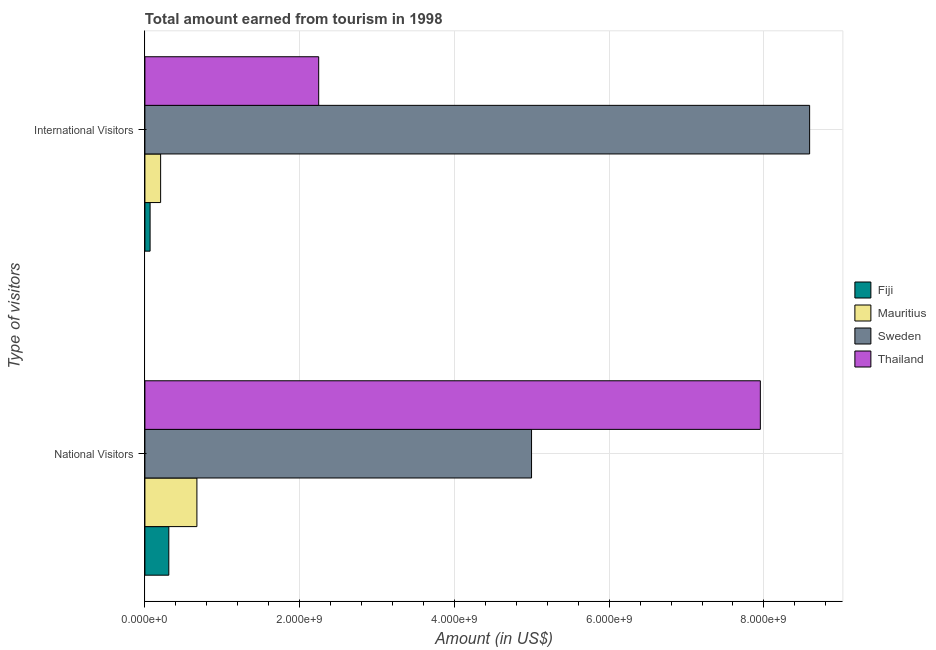Are the number of bars per tick equal to the number of legend labels?
Your answer should be very brief. Yes. Are the number of bars on each tick of the Y-axis equal?
Offer a terse response. Yes. What is the label of the 2nd group of bars from the top?
Give a very brief answer. National Visitors. What is the amount earned from international visitors in Mauritius?
Give a very brief answer. 2.03e+08. Across all countries, what is the maximum amount earned from international visitors?
Give a very brief answer. 8.59e+09. Across all countries, what is the minimum amount earned from national visitors?
Provide a succinct answer. 3.09e+08. In which country was the amount earned from international visitors minimum?
Your response must be concise. Fiji. What is the total amount earned from international visitors in the graph?
Offer a very short reply. 1.11e+1. What is the difference between the amount earned from national visitors in Sweden and that in Fiji?
Your answer should be very brief. 4.69e+09. What is the difference between the amount earned from international visitors in Sweden and the amount earned from national visitors in Mauritius?
Give a very brief answer. 7.92e+09. What is the average amount earned from national visitors per country?
Ensure brevity in your answer.  3.48e+09. What is the difference between the amount earned from international visitors and amount earned from national visitors in Fiji?
Provide a succinct answer. -2.42e+08. What is the ratio of the amount earned from international visitors in Mauritius to that in Thailand?
Your answer should be compact. 0.09. What does the 3rd bar from the top in National Visitors represents?
Give a very brief answer. Mauritius. What does the 2nd bar from the bottom in National Visitors represents?
Your answer should be very brief. Mauritius. Are all the bars in the graph horizontal?
Make the answer very short. Yes. What is the difference between two consecutive major ticks on the X-axis?
Provide a short and direct response. 2.00e+09. Are the values on the major ticks of X-axis written in scientific E-notation?
Give a very brief answer. Yes. Where does the legend appear in the graph?
Make the answer very short. Center right. How many legend labels are there?
Offer a very short reply. 4. What is the title of the graph?
Your response must be concise. Total amount earned from tourism in 1998. Does "Moldova" appear as one of the legend labels in the graph?
Offer a very short reply. No. What is the label or title of the X-axis?
Your answer should be compact. Amount (in US$). What is the label or title of the Y-axis?
Your answer should be very brief. Type of visitors. What is the Amount (in US$) in Fiji in National Visitors?
Provide a short and direct response. 3.09e+08. What is the Amount (in US$) of Mauritius in National Visitors?
Offer a very short reply. 6.72e+08. What is the Amount (in US$) of Sweden in National Visitors?
Ensure brevity in your answer.  5.00e+09. What is the Amount (in US$) in Thailand in National Visitors?
Your response must be concise. 7.95e+09. What is the Amount (in US$) of Fiji in International Visitors?
Offer a very short reply. 6.70e+07. What is the Amount (in US$) of Mauritius in International Visitors?
Make the answer very short. 2.03e+08. What is the Amount (in US$) of Sweden in International Visitors?
Provide a short and direct response. 8.59e+09. What is the Amount (in US$) in Thailand in International Visitors?
Your answer should be compact. 2.25e+09. Across all Type of visitors, what is the maximum Amount (in US$) of Fiji?
Give a very brief answer. 3.09e+08. Across all Type of visitors, what is the maximum Amount (in US$) of Mauritius?
Your answer should be compact. 6.72e+08. Across all Type of visitors, what is the maximum Amount (in US$) of Sweden?
Your response must be concise. 8.59e+09. Across all Type of visitors, what is the maximum Amount (in US$) of Thailand?
Your answer should be very brief. 7.95e+09. Across all Type of visitors, what is the minimum Amount (in US$) in Fiji?
Provide a short and direct response. 6.70e+07. Across all Type of visitors, what is the minimum Amount (in US$) of Mauritius?
Offer a terse response. 2.03e+08. Across all Type of visitors, what is the minimum Amount (in US$) in Sweden?
Keep it short and to the point. 5.00e+09. Across all Type of visitors, what is the minimum Amount (in US$) in Thailand?
Your answer should be very brief. 2.25e+09. What is the total Amount (in US$) of Fiji in the graph?
Your response must be concise. 3.76e+08. What is the total Amount (in US$) of Mauritius in the graph?
Your answer should be compact. 8.75e+08. What is the total Amount (in US$) of Sweden in the graph?
Provide a succinct answer. 1.36e+1. What is the total Amount (in US$) of Thailand in the graph?
Keep it short and to the point. 1.02e+1. What is the difference between the Amount (in US$) in Fiji in National Visitors and that in International Visitors?
Your answer should be very brief. 2.42e+08. What is the difference between the Amount (in US$) of Mauritius in National Visitors and that in International Visitors?
Offer a very short reply. 4.69e+08. What is the difference between the Amount (in US$) in Sweden in National Visitors and that in International Visitors?
Your answer should be compact. -3.59e+09. What is the difference between the Amount (in US$) in Thailand in National Visitors and that in International Visitors?
Offer a terse response. 5.71e+09. What is the difference between the Amount (in US$) of Fiji in National Visitors and the Amount (in US$) of Mauritius in International Visitors?
Keep it short and to the point. 1.06e+08. What is the difference between the Amount (in US$) in Fiji in National Visitors and the Amount (in US$) in Sweden in International Visitors?
Your answer should be compact. -8.28e+09. What is the difference between the Amount (in US$) of Fiji in National Visitors and the Amount (in US$) of Thailand in International Visitors?
Ensure brevity in your answer.  -1.94e+09. What is the difference between the Amount (in US$) in Mauritius in National Visitors and the Amount (in US$) in Sweden in International Visitors?
Give a very brief answer. -7.92e+09. What is the difference between the Amount (in US$) in Mauritius in National Visitors and the Amount (in US$) in Thailand in International Visitors?
Your answer should be very brief. -1.57e+09. What is the difference between the Amount (in US$) in Sweden in National Visitors and the Amount (in US$) in Thailand in International Visitors?
Provide a short and direct response. 2.75e+09. What is the average Amount (in US$) of Fiji per Type of visitors?
Provide a succinct answer. 1.88e+08. What is the average Amount (in US$) in Mauritius per Type of visitors?
Your answer should be very brief. 4.38e+08. What is the average Amount (in US$) in Sweden per Type of visitors?
Your answer should be compact. 6.79e+09. What is the average Amount (in US$) in Thailand per Type of visitors?
Provide a short and direct response. 5.10e+09. What is the difference between the Amount (in US$) in Fiji and Amount (in US$) in Mauritius in National Visitors?
Offer a terse response. -3.63e+08. What is the difference between the Amount (in US$) in Fiji and Amount (in US$) in Sweden in National Visitors?
Your response must be concise. -4.69e+09. What is the difference between the Amount (in US$) in Fiji and Amount (in US$) in Thailand in National Visitors?
Your answer should be compact. -7.64e+09. What is the difference between the Amount (in US$) in Mauritius and Amount (in US$) in Sweden in National Visitors?
Give a very brief answer. -4.32e+09. What is the difference between the Amount (in US$) of Mauritius and Amount (in US$) of Thailand in National Visitors?
Offer a terse response. -7.28e+09. What is the difference between the Amount (in US$) in Sweden and Amount (in US$) in Thailand in National Visitors?
Offer a terse response. -2.96e+09. What is the difference between the Amount (in US$) in Fiji and Amount (in US$) in Mauritius in International Visitors?
Offer a very short reply. -1.36e+08. What is the difference between the Amount (in US$) in Fiji and Amount (in US$) in Sweden in International Visitors?
Offer a terse response. -8.52e+09. What is the difference between the Amount (in US$) in Fiji and Amount (in US$) in Thailand in International Visitors?
Provide a short and direct response. -2.18e+09. What is the difference between the Amount (in US$) in Mauritius and Amount (in US$) in Sweden in International Visitors?
Provide a short and direct response. -8.39e+09. What is the difference between the Amount (in US$) of Mauritius and Amount (in US$) of Thailand in International Visitors?
Give a very brief answer. -2.04e+09. What is the difference between the Amount (in US$) of Sweden and Amount (in US$) of Thailand in International Visitors?
Your answer should be very brief. 6.34e+09. What is the ratio of the Amount (in US$) in Fiji in National Visitors to that in International Visitors?
Keep it short and to the point. 4.61. What is the ratio of the Amount (in US$) of Mauritius in National Visitors to that in International Visitors?
Your answer should be very brief. 3.31. What is the ratio of the Amount (in US$) in Sweden in National Visitors to that in International Visitors?
Your response must be concise. 0.58. What is the ratio of the Amount (in US$) of Thailand in National Visitors to that in International Visitors?
Provide a succinct answer. 3.54. What is the difference between the highest and the second highest Amount (in US$) in Fiji?
Offer a very short reply. 2.42e+08. What is the difference between the highest and the second highest Amount (in US$) in Mauritius?
Your answer should be compact. 4.69e+08. What is the difference between the highest and the second highest Amount (in US$) of Sweden?
Give a very brief answer. 3.59e+09. What is the difference between the highest and the second highest Amount (in US$) of Thailand?
Ensure brevity in your answer.  5.71e+09. What is the difference between the highest and the lowest Amount (in US$) in Fiji?
Offer a terse response. 2.42e+08. What is the difference between the highest and the lowest Amount (in US$) of Mauritius?
Your answer should be compact. 4.69e+08. What is the difference between the highest and the lowest Amount (in US$) of Sweden?
Keep it short and to the point. 3.59e+09. What is the difference between the highest and the lowest Amount (in US$) of Thailand?
Your answer should be very brief. 5.71e+09. 